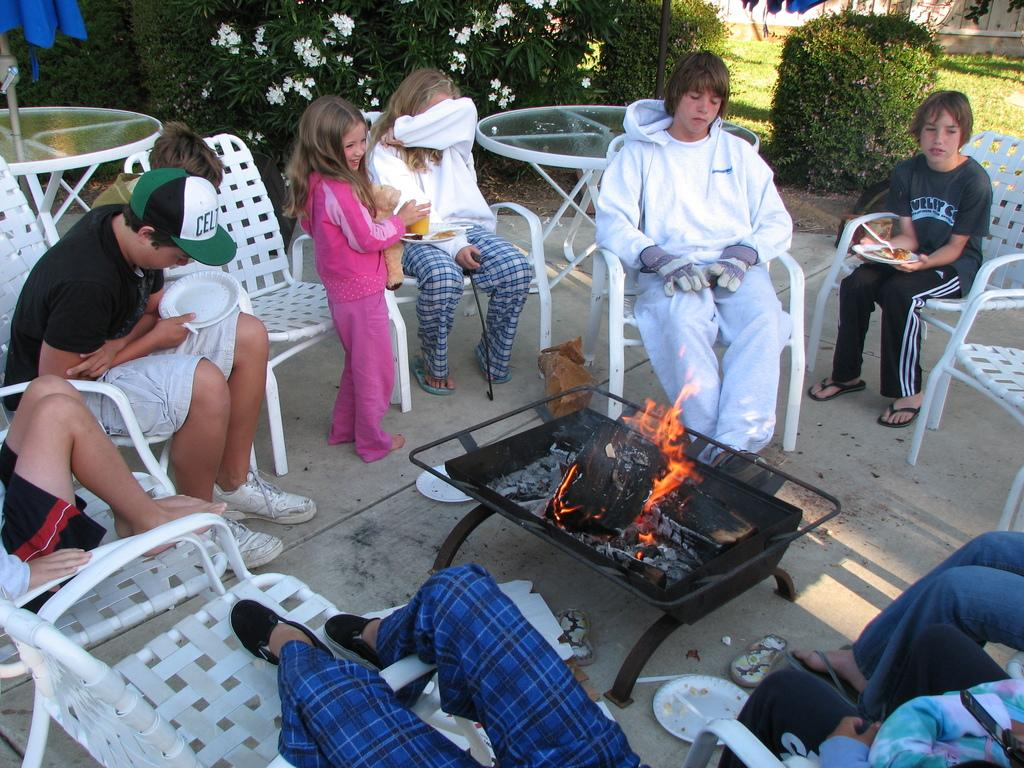<image>
Offer a succinct explanation of the picture presented. A family sits around the fire, including a teenager with a Celtics hat. 